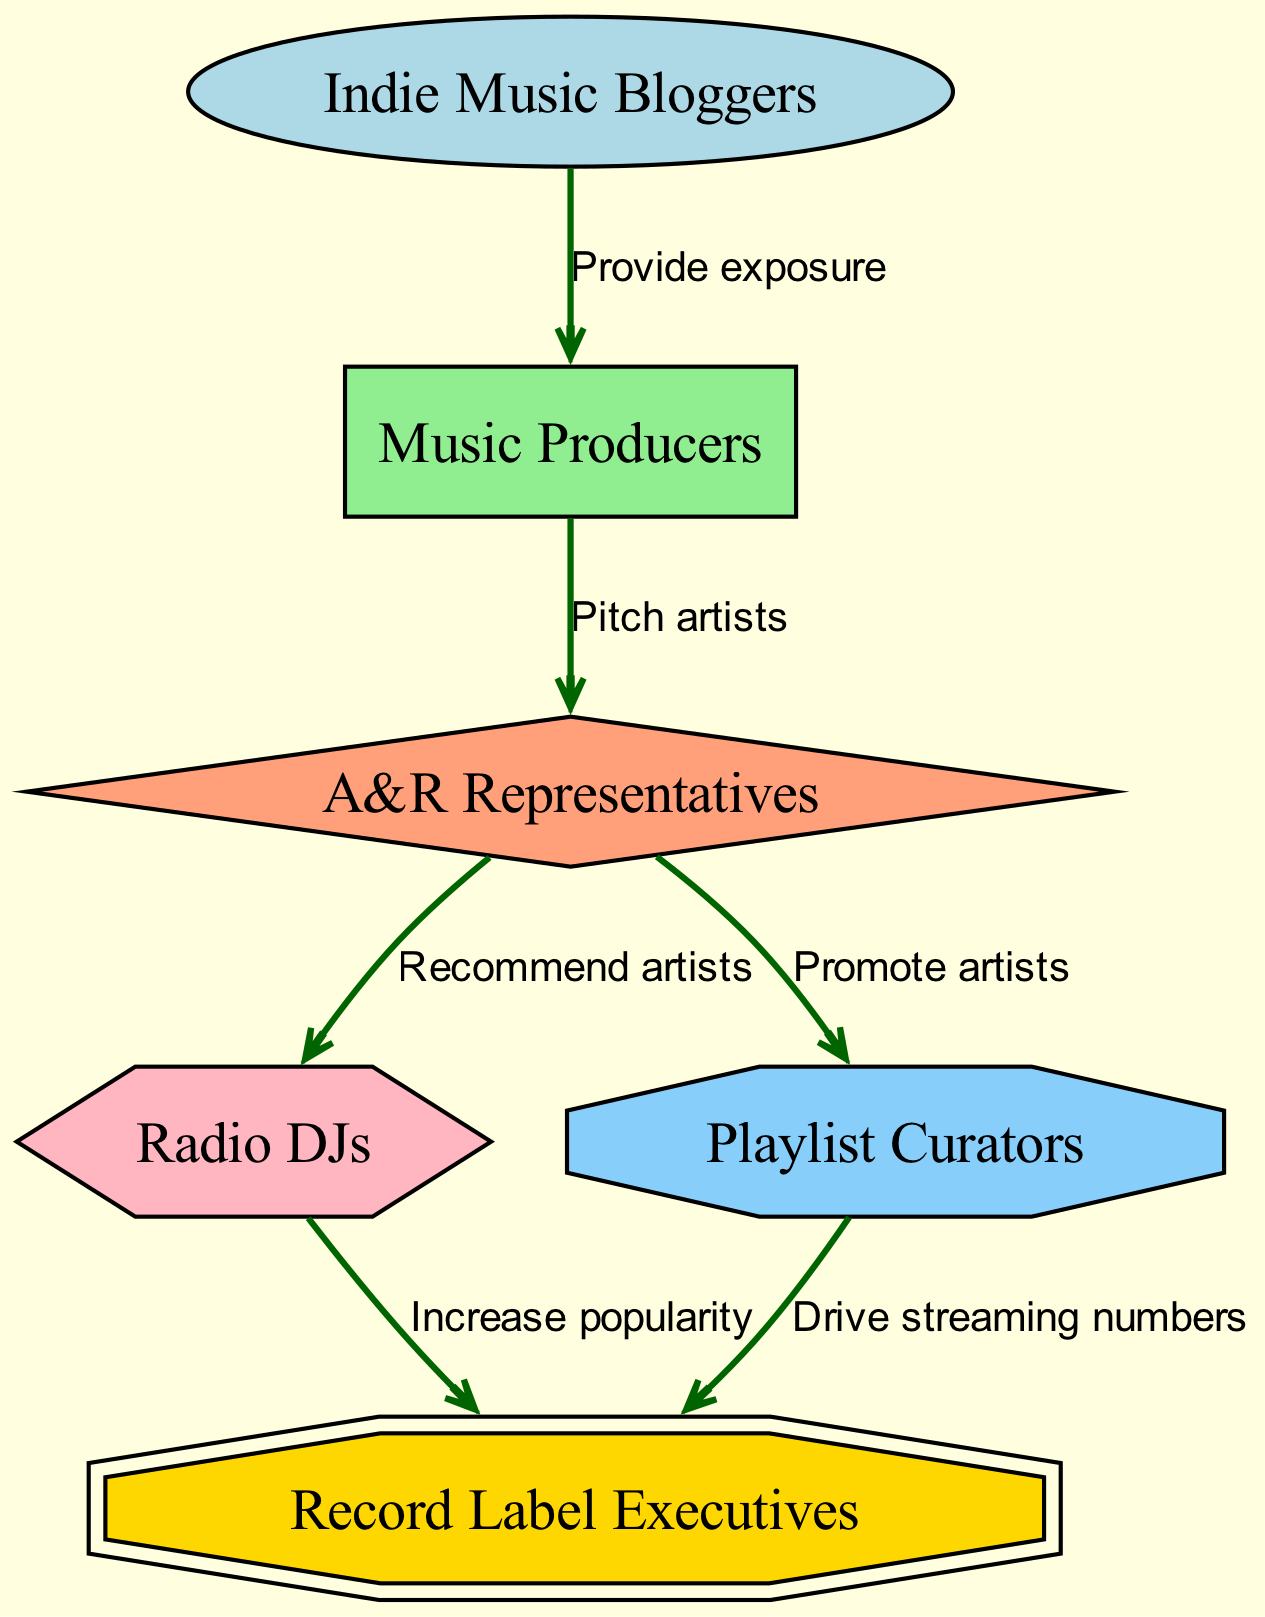What is the top node in the hierarchy? The top node represents the starting point or the highest level in the food chain. In this diagram, "Indie Music Bloggers" is at the top, indicating they provide initial exposure.
Answer: Indie Music Bloggers How many nodes are in the diagram? Counting each unique entity in the diagram, we find six distinct nodes representing different roles in the music industry, which helps identify all participants in the food chain.
Answer: 6 Which two nodes are directly connected to A&R Representatives? A&R Representatives are connected to "Radio DJs" and "Playlist Curators." Each connection represents a recommendation and promotion relationship, which means they interact with both nodes directly.
Answer: Radio DJs and Playlist Curators What do Music Producers do to A&R Representatives? Music Producers "Pitch artists" to A&R Representatives. This connection indicates the action that Music Producers take to introduce their artists to A&R for further development.
Answer: Pitch artists Which node helps drive streaming numbers to Record Label Executives? The edge shows that "Playlist Curators" drive streaming numbers towards "Record Label Executives." This indicates that they play a pivotal role in increasing an artist's visibility through playlists.
Answer: Playlist Curators What role do Radio DJs have in artist promotion? The edge shows that Radio DJs "Increase popularity," demonstrating their importance in making an artist more well-known through radio play.
Answer: Increase popularity Which node provides exposure to Music Producers? The edge indicates that "Indie Music Bloggers" provide exposure to Music Producers. This showcases how bloggers play a crucial role in the initial promotion of upcoming artists.
Answer: Provide exposure How many edges are there in total in this diagram? Each connection between nodes represents an edge. Counting all the edges shows there are five in total, which helps establish the flow of influence among the professionals.
Answer: 5 What do A&R Representatives do to Radio DJs? A&R Representatives "Recommend artists" to Radio DJs. This shows their role as intermediaries who suggest which artists should be promoted on the radio airwaves.
Answer: Recommend artists 